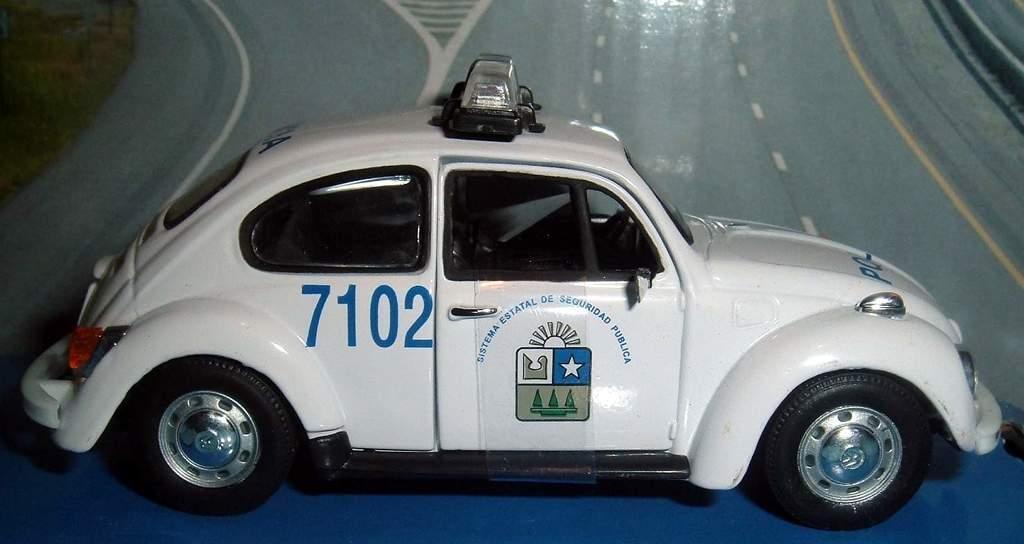Please provide a concise description of this image. In this image we can see a white color car, on the car, we can see the lights and some text, in the background, it looks like the road. 